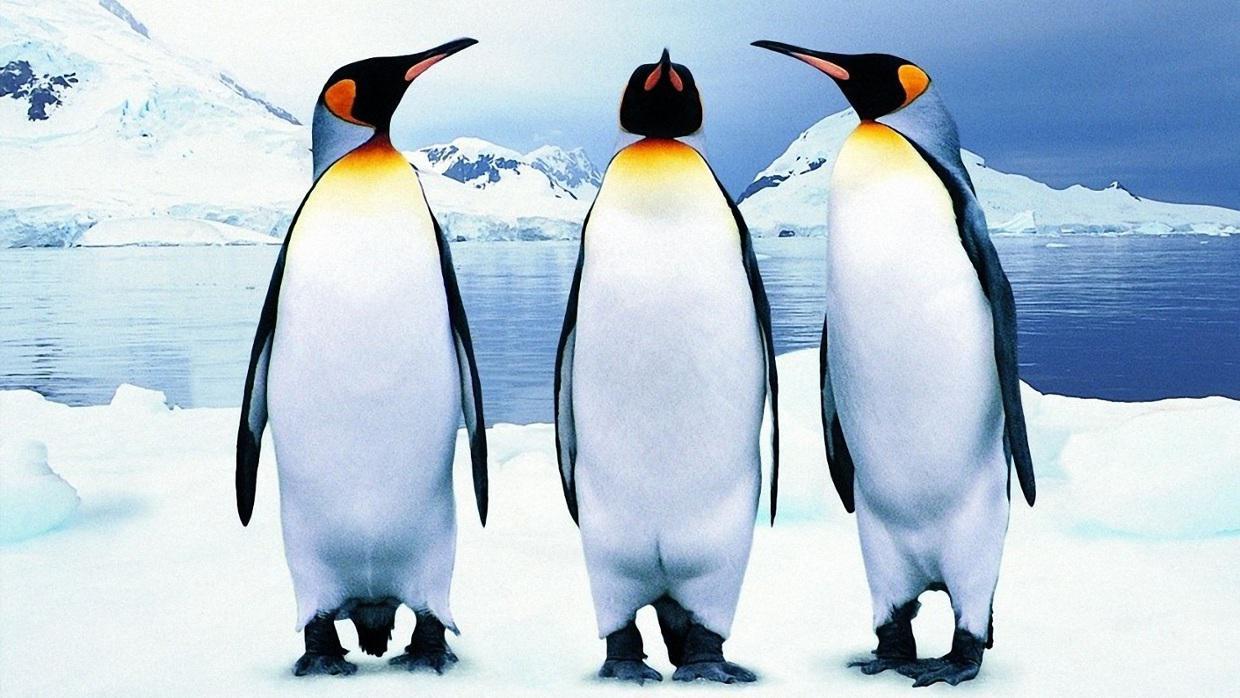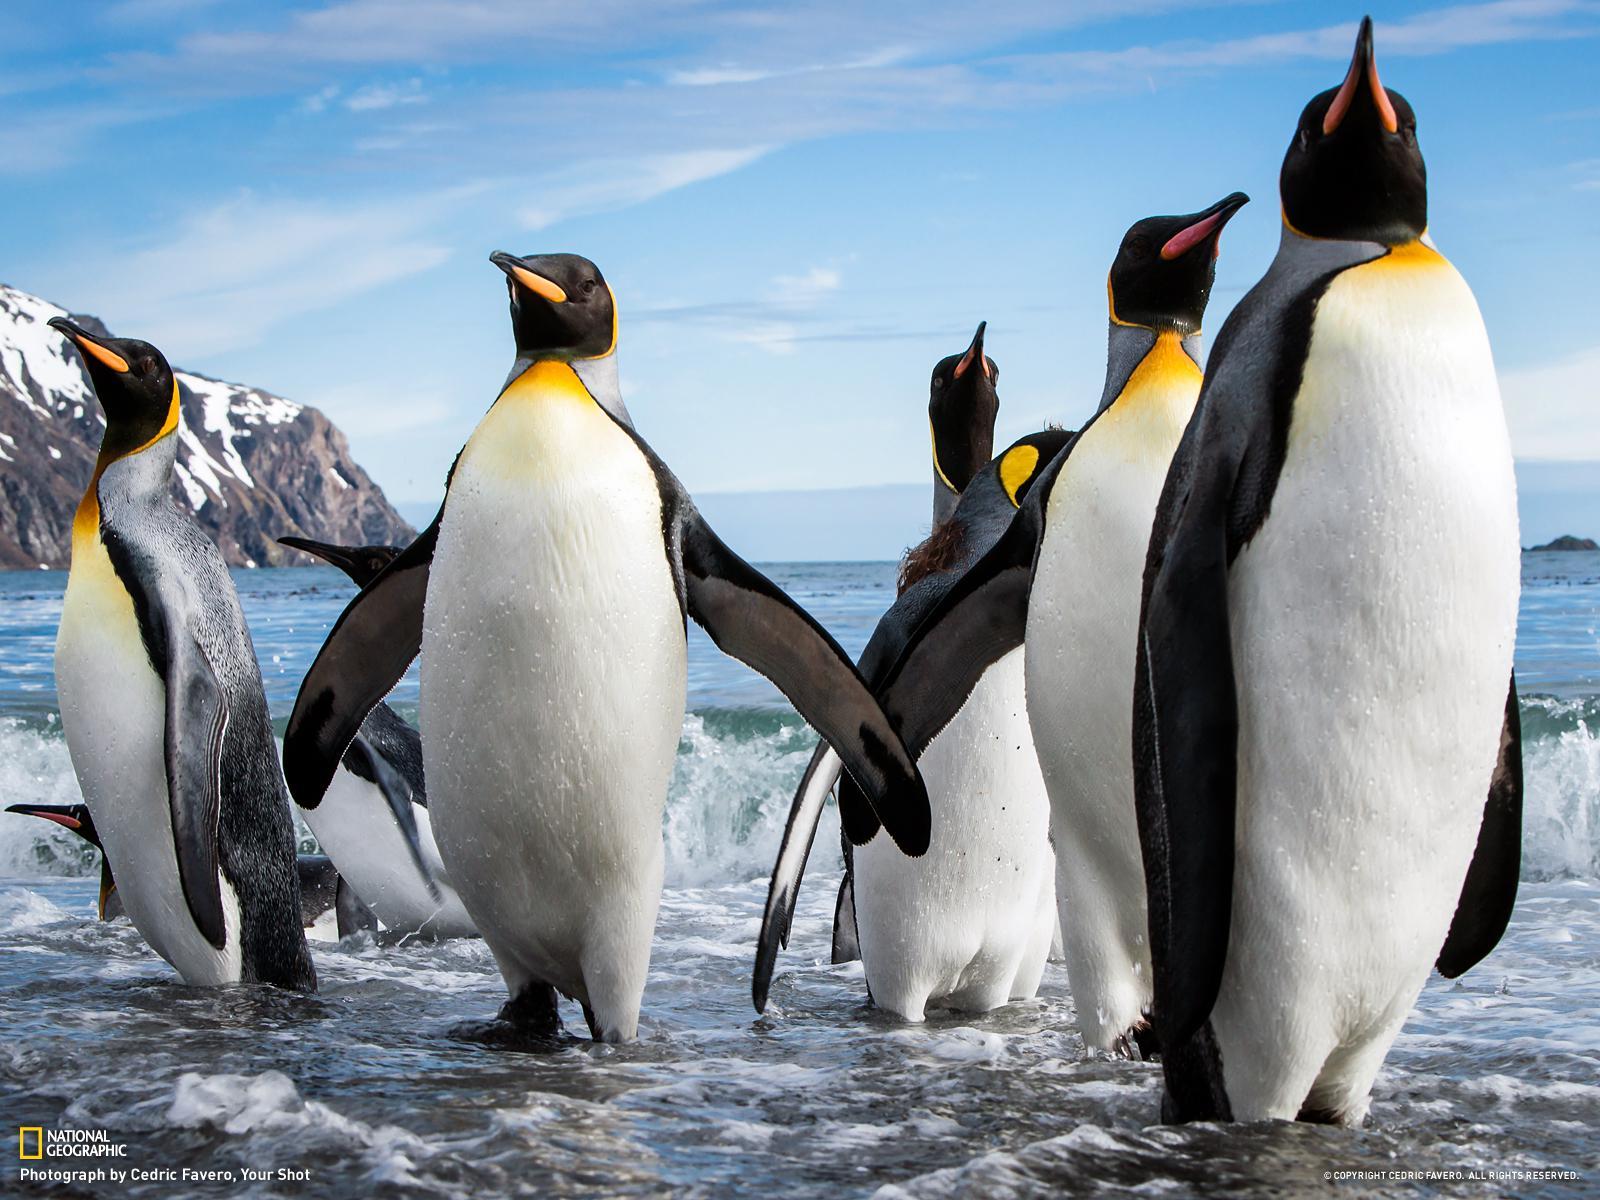The first image is the image on the left, the second image is the image on the right. Considering the images on both sides, is "Left image contains multiple penguins with backs turned to the camera." valid? Answer yes or no. No. 